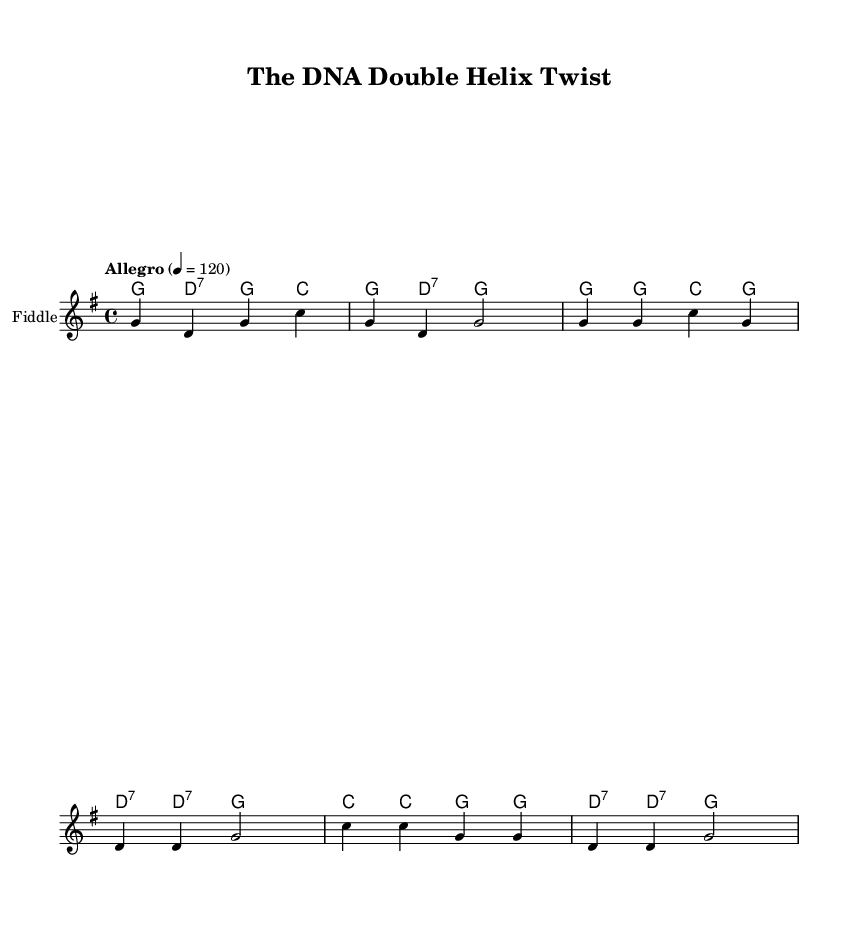What is the key signature of this music? The key signature is G major, which has one sharp (F#). This can be identified by looking at the key signature section of the sheet music.
Answer: G major What is the time signature of this music? The time signature is 4/4, indicating there are four beats per measure and the quarter note gets one beat. This is shown at the beginning of the score.
Answer: 4/4 What is the tempo marking of this music? The tempo marking is "Allegro," followed by a numerical indication of 4 beats per minute equals 120. This is stated near the top of the music sheet.
Answer: Allegro, 120 How many measures are in the verse? The verse consists of four measures, which can be counted in the music notation provided. Each set of vertical lines indicates a separate measure.
Answer: 4 What instruments are used in this piece? The instruments specified are the fiddle and the banjo, as indicated in the staff and chord names sections of the sheet music.
Answer: Fiddle and Banjo How many times is the chorus repeated? The chorus is repeated once, following the verse and clearly demarcated by structure in the sheet music.
Answer: Once What is the overall structure of this song? The song has an introduction, followed by the verse and then the chorus, which alternates in a typical verse-chorus format. This can be observed through the arrangement in the sheet music.
Answer: Intro, Verse, Chorus 